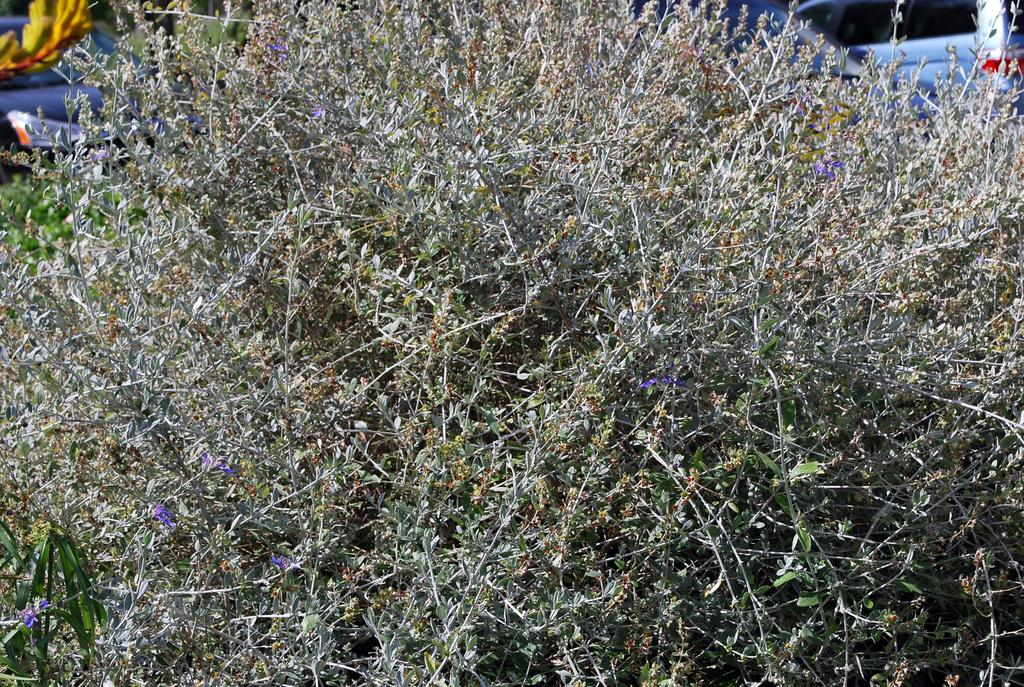What is the main subject of the image? The main subject of the image is a plant. Can you describe any specific features of the plant? There are leaves visible in the image. What type of writing can be seen on the leaves in the image? There is no writing visible on the leaves in the image. Can you hear any thunder in the background of the image? There is no sound or background noise present in the image, as it is a still photograph of a plant. 